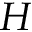Convert formula to latex. <formula><loc_0><loc_0><loc_500><loc_500>H</formula> 